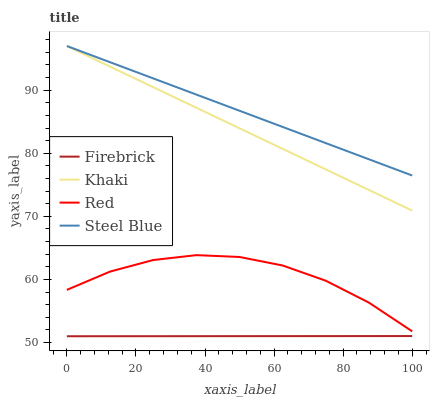Does Firebrick have the minimum area under the curve?
Answer yes or no. Yes. Does Steel Blue have the maximum area under the curve?
Answer yes or no. Yes. Does Khaki have the minimum area under the curve?
Answer yes or no. No. Does Khaki have the maximum area under the curve?
Answer yes or no. No. Is Firebrick the smoothest?
Answer yes or no. Yes. Is Red the roughest?
Answer yes or no. Yes. Is Khaki the smoothest?
Answer yes or no. No. Is Khaki the roughest?
Answer yes or no. No. Does Firebrick have the lowest value?
Answer yes or no. Yes. Does Khaki have the lowest value?
Answer yes or no. No. Does Steel Blue have the highest value?
Answer yes or no. Yes. Does Red have the highest value?
Answer yes or no. No. Is Red less than Steel Blue?
Answer yes or no. Yes. Is Red greater than Firebrick?
Answer yes or no. Yes. Does Steel Blue intersect Khaki?
Answer yes or no. Yes. Is Steel Blue less than Khaki?
Answer yes or no. No. Is Steel Blue greater than Khaki?
Answer yes or no. No. Does Red intersect Steel Blue?
Answer yes or no. No. 